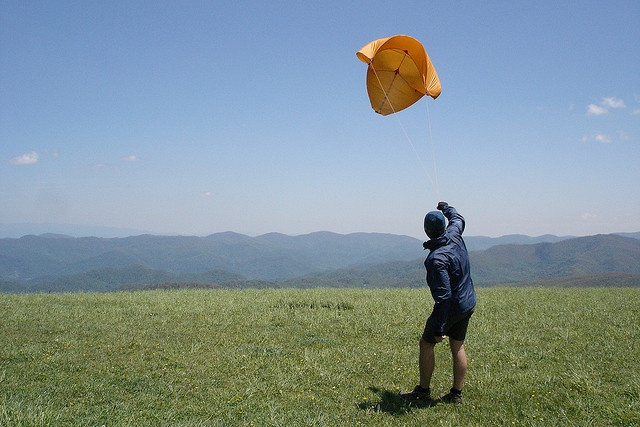Describe the objects in this image and their specific colors. I can see people in gray, black, and navy tones and kite in gray, brown, maroon, and orange tones in this image. 